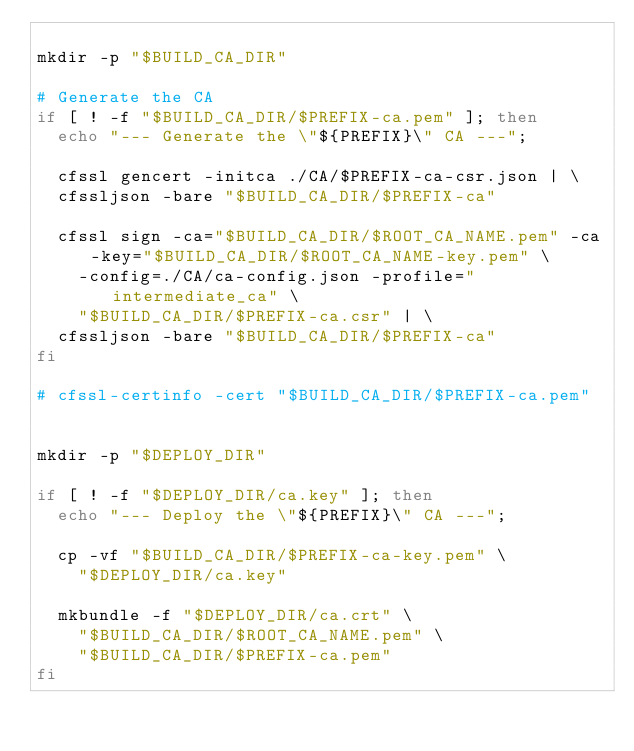Convert code to text. <code><loc_0><loc_0><loc_500><loc_500><_Bash_>
mkdir -p "$BUILD_CA_DIR"

# Generate the CA
if [ ! -f "$BUILD_CA_DIR/$PREFIX-ca.pem" ]; then
  echo "--- Generate the \"${PREFIX}\" CA ---";

  cfssl gencert -initca ./CA/$PREFIX-ca-csr.json | \
  cfssljson -bare "$BUILD_CA_DIR/$PREFIX-ca"

  cfssl sign -ca="$BUILD_CA_DIR/$ROOT_CA_NAME.pem" -ca-key="$BUILD_CA_DIR/$ROOT_CA_NAME-key.pem" \
    -config=./CA/ca-config.json -profile="intermediate_ca" \
    "$BUILD_CA_DIR/$PREFIX-ca.csr" | \
  cfssljson -bare "$BUILD_CA_DIR/$PREFIX-ca"
fi

# cfssl-certinfo -cert "$BUILD_CA_DIR/$PREFIX-ca.pem"


mkdir -p "$DEPLOY_DIR"

if [ ! -f "$DEPLOY_DIR/ca.key" ]; then
  echo "--- Deploy the \"${PREFIX}\" CA ---";

  cp -vf "$BUILD_CA_DIR/$PREFIX-ca-key.pem" \
    "$DEPLOY_DIR/ca.key"

  mkbundle -f "$DEPLOY_DIR/ca.crt" \
    "$BUILD_CA_DIR/$ROOT_CA_NAME.pem" \
    "$BUILD_CA_DIR/$PREFIX-ca.pem"
fi
</code> 